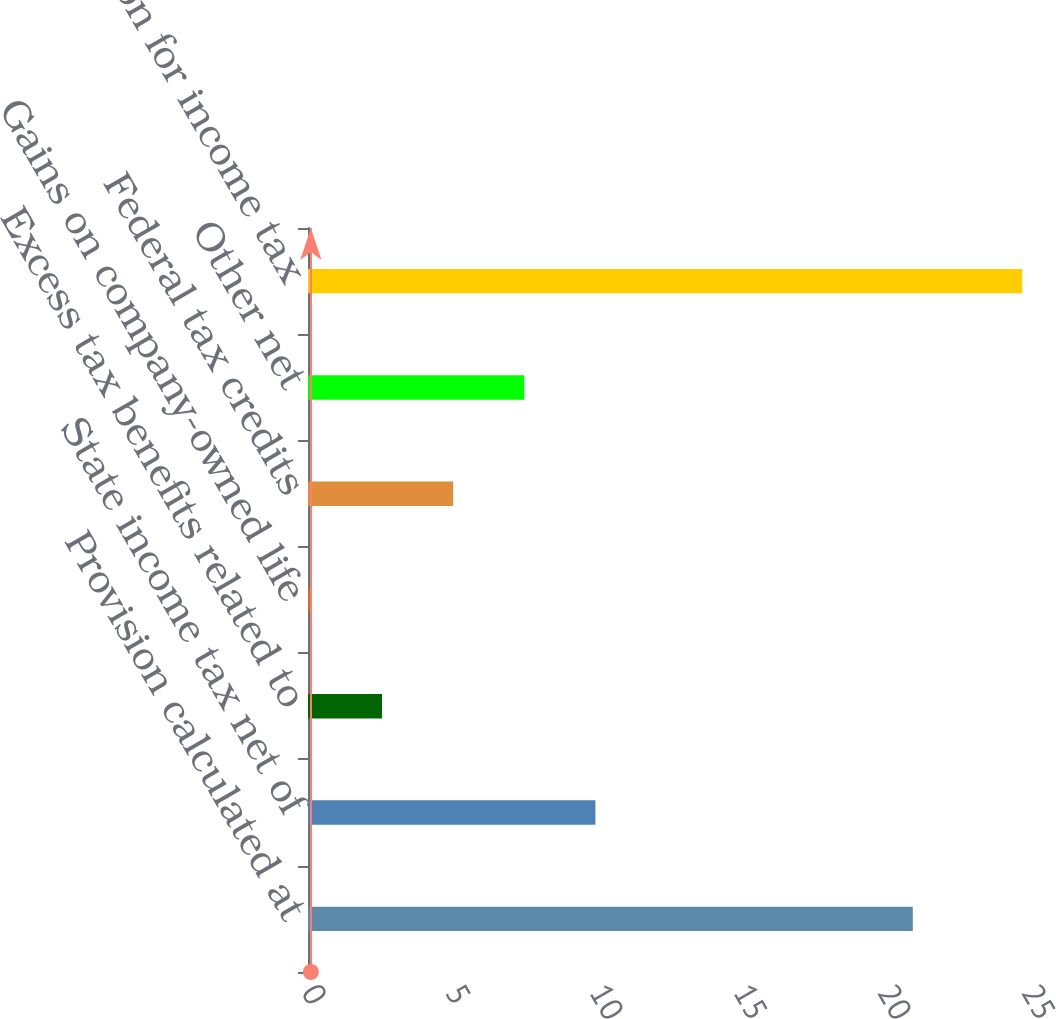Convert chart. <chart><loc_0><loc_0><loc_500><loc_500><bar_chart><fcel>Provision calculated at<fcel>State income tax net of<fcel>Excess tax benefits related to<fcel>Gains on company-owned life<fcel>Federal tax credits<fcel>Other net<fcel>Total provision for income tax<nl><fcel>21<fcel>9.98<fcel>2.57<fcel>0.1<fcel>5.04<fcel>7.51<fcel>24.8<nl></chart> 